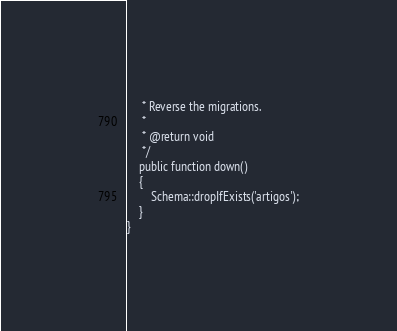<code> <loc_0><loc_0><loc_500><loc_500><_PHP_>     * Reverse the migrations.
     *
     * @return void
     */
    public function down()
    {
        Schema::dropIfExists('artigos');
    }
}
</code> 